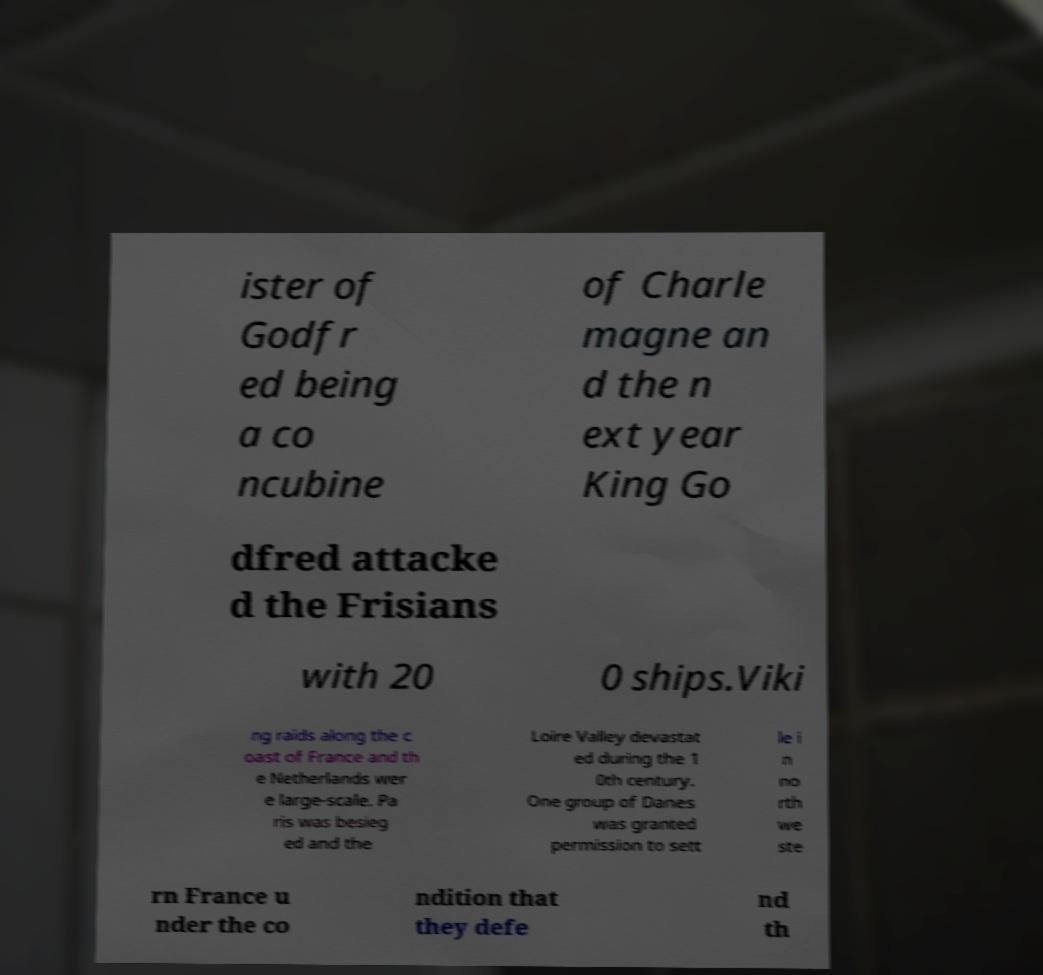Could you assist in decoding the text presented in this image and type it out clearly? ister of Godfr ed being a co ncubine of Charle magne an d the n ext year King Go dfred attacke d the Frisians with 20 0 ships.Viki ng raids along the c oast of France and th e Netherlands wer e large-scale. Pa ris was besieg ed and the Loire Valley devastat ed during the 1 0th century. One group of Danes was granted permission to sett le i n no rth we ste rn France u nder the co ndition that they defe nd th 